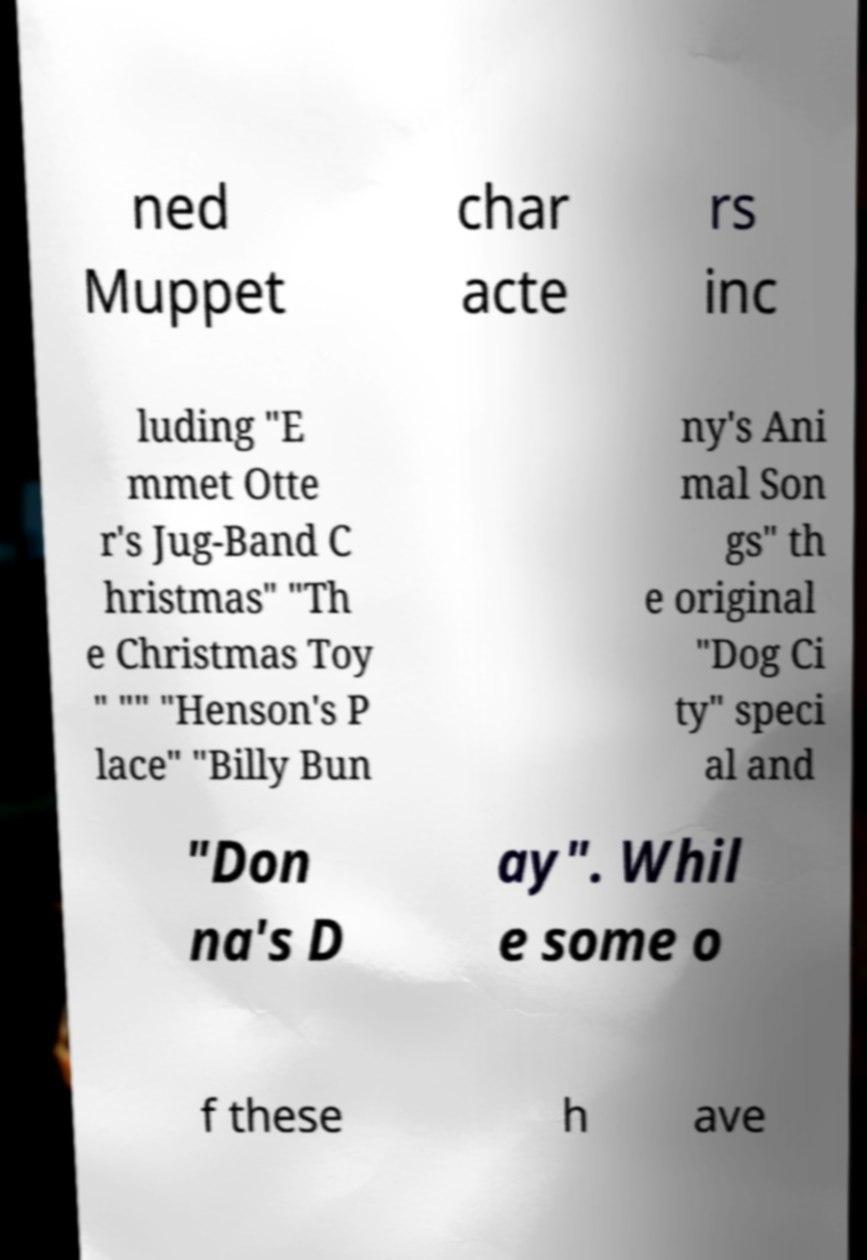What messages or text are displayed in this image? I need them in a readable, typed format. ned Muppet char acte rs inc luding "E mmet Otte r's Jug-Band C hristmas" "Th e Christmas Toy " "" "Henson's P lace" "Billy Bun ny's Ani mal Son gs" th e original "Dog Ci ty" speci al and "Don na's D ay". Whil e some o f these h ave 